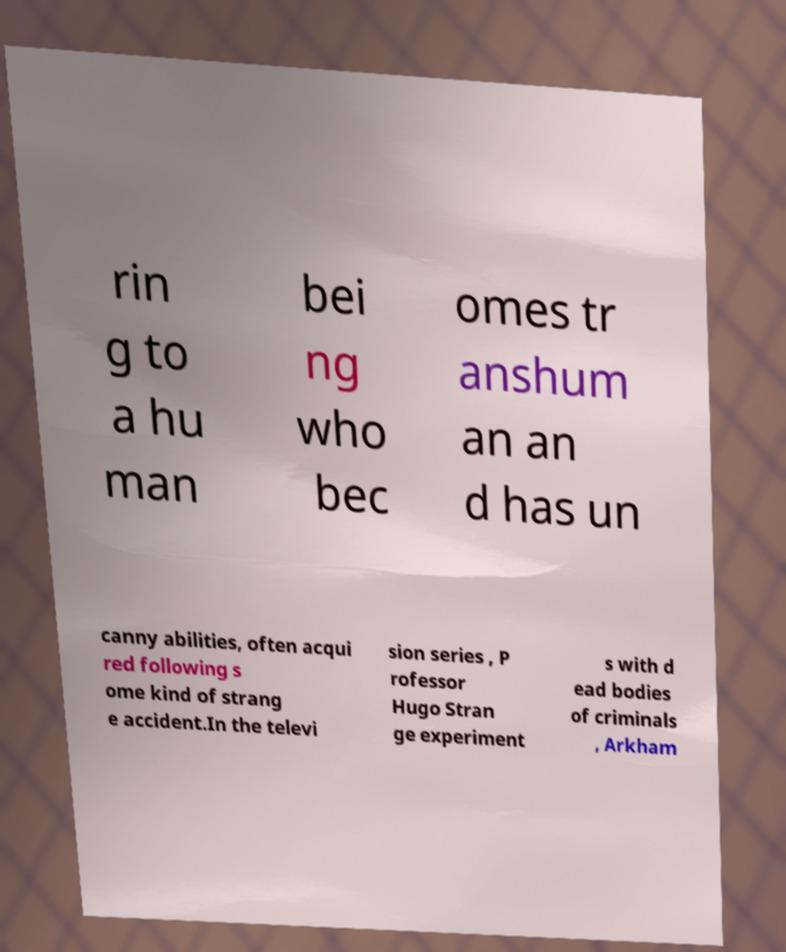There's text embedded in this image that I need extracted. Can you transcribe it verbatim? rin g to a hu man bei ng who bec omes tr anshum an an d has un canny abilities, often acqui red following s ome kind of strang e accident.In the televi sion series , P rofessor Hugo Stran ge experiment s with d ead bodies of criminals , Arkham 